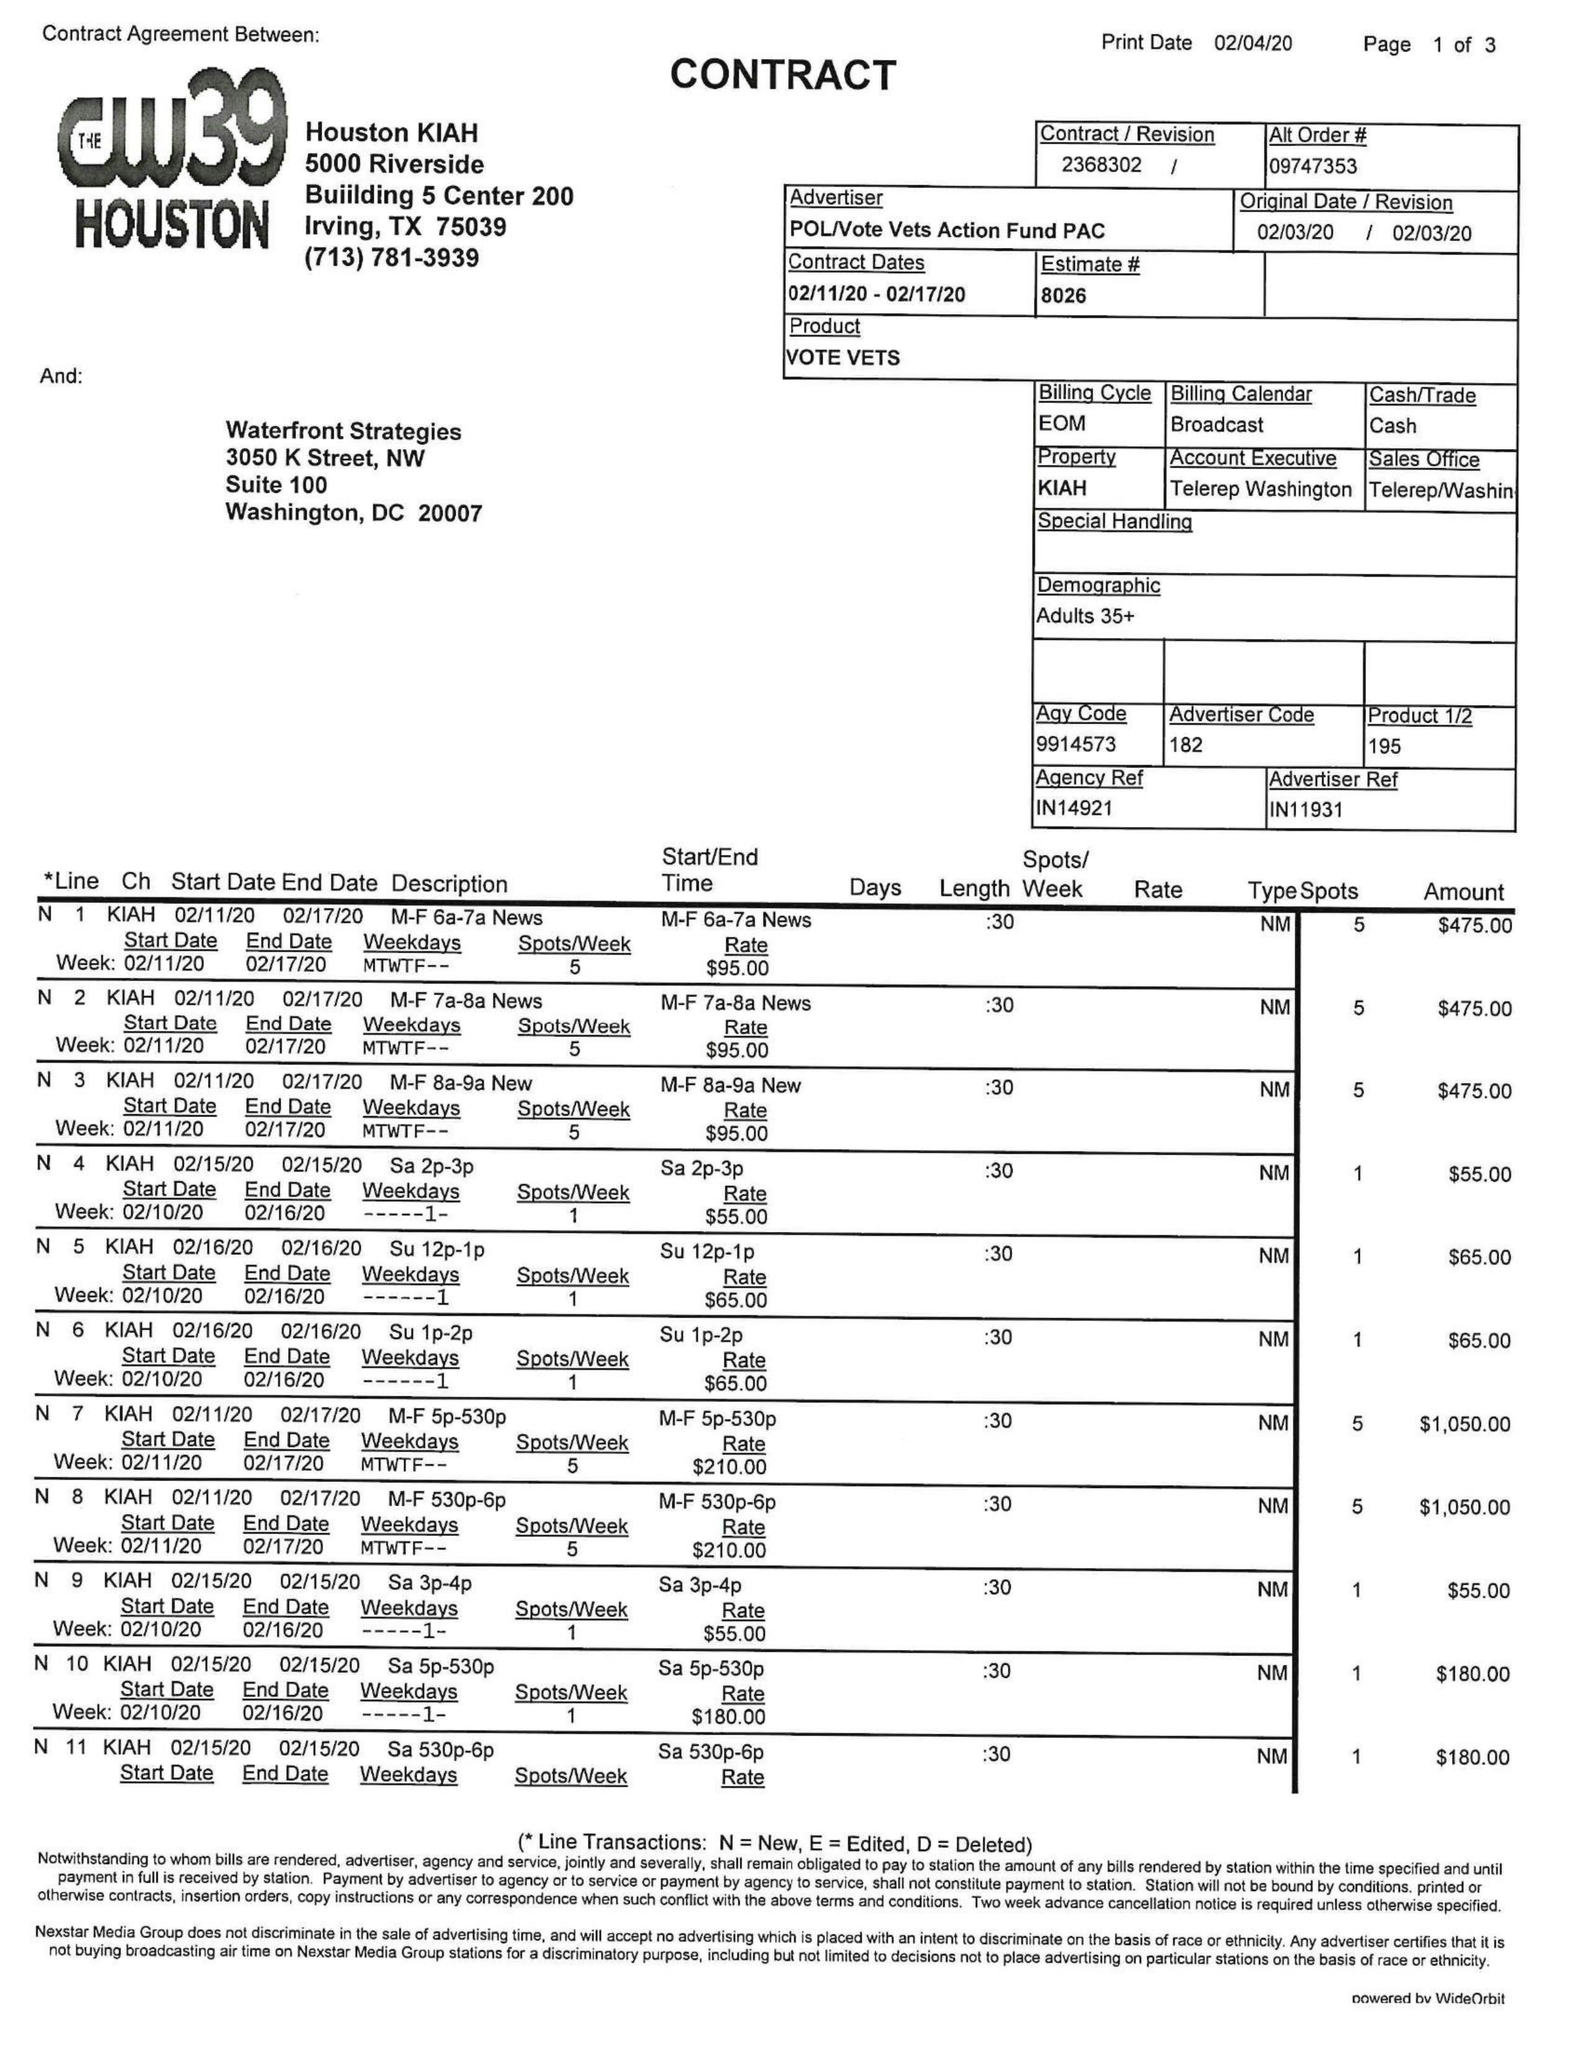What is the value for the flight_to?
Answer the question using a single word or phrase. 02/17/20 